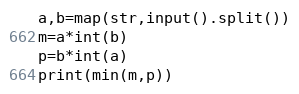<code> <loc_0><loc_0><loc_500><loc_500><_Python_>a,b=map(str,input().split())
m=a*int(b)
p=b*int(a)
print(min(m,p))</code> 